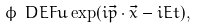<formula> <loc_0><loc_0><loc_500><loc_500>\phi \ D E F u \exp ( i \vec { p } \cdot \vec { x } - i E t ) ,</formula> 